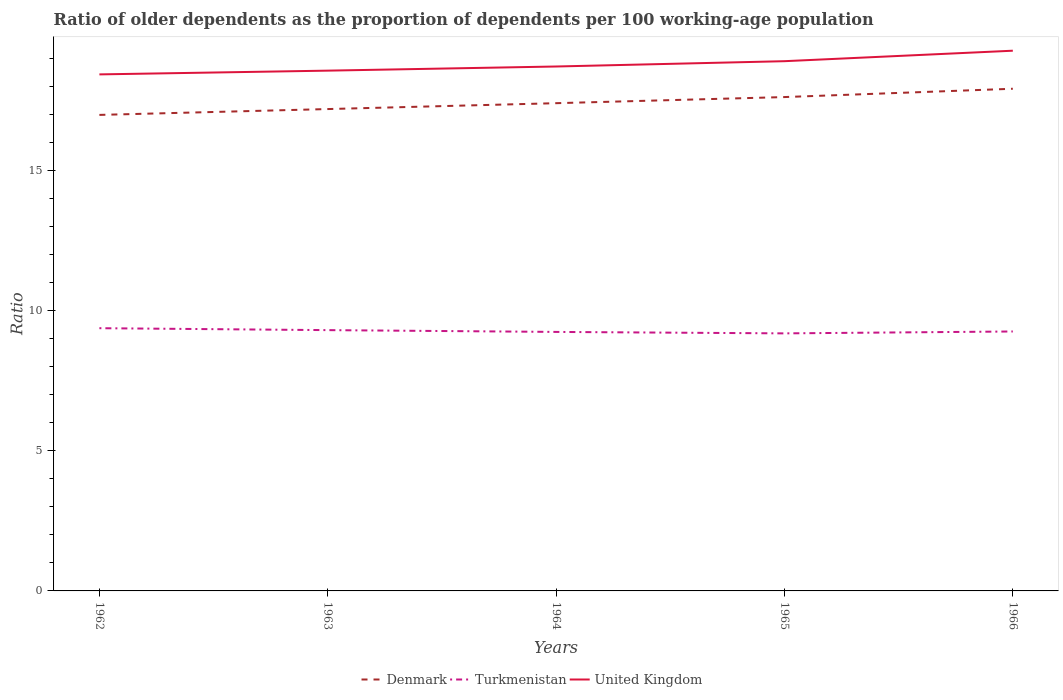How many different coloured lines are there?
Ensure brevity in your answer.  3. Across all years, what is the maximum age dependency ratio(old) in United Kingdom?
Keep it short and to the point. 18.43. In which year was the age dependency ratio(old) in Denmark maximum?
Your answer should be compact. 1962. What is the total age dependency ratio(old) in Denmark in the graph?
Offer a terse response. -0.43. What is the difference between the highest and the second highest age dependency ratio(old) in Denmark?
Make the answer very short. 0.93. How many years are there in the graph?
Provide a succinct answer. 5. Are the values on the major ticks of Y-axis written in scientific E-notation?
Make the answer very short. No. Does the graph contain grids?
Make the answer very short. No. How are the legend labels stacked?
Give a very brief answer. Horizontal. What is the title of the graph?
Give a very brief answer. Ratio of older dependents as the proportion of dependents per 100 working-age population. Does "United Kingdom" appear as one of the legend labels in the graph?
Give a very brief answer. Yes. What is the label or title of the X-axis?
Keep it short and to the point. Years. What is the label or title of the Y-axis?
Your answer should be very brief. Ratio. What is the Ratio in Denmark in 1962?
Provide a succinct answer. 16.98. What is the Ratio of Turkmenistan in 1962?
Your response must be concise. 9.37. What is the Ratio of United Kingdom in 1962?
Your answer should be very brief. 18.43. What is the Ratio in Denmark in 1963?
Provide a succinct answer. 17.19. What is the Ratio in Turkmenistan in 1963?
Ensure brevity in your answer.  9.3. What is the Ratio of United Kingdom in 1963?
Offer a very short reply. 18.56. What is the Ratio of Denmark in 1964?
Give a very brief answer. 17.4. What is the Ratio of Turkmenistan in 1964?
Offer a very short reply. 9.24. What is the Ratio of United Kingdom in 1964?
Your answer should be very brief. 18.71. What is the Ratio of Denmark in 1965?
Offer a very short reply. 17.62. What is the Ratio of Turkmenistan in 1965?
Your response must be concise. 9.19. What is the Ratio of United Kingdom in 1965?
Offer a very short reply. 18.9. What is the Ratio of Denmark in 1966?
Give a very brief answer. 17.91. What is the Ratio in Turkmenistan in 1966?
Offer a very short reply. 9.25. What is the Ratio of United Kingdom in 1966?
Provide a short and direct response. 19.27. Across all years, what is the maximum Ratio in Denmark?
Your response must be concise. 17.91. Across all years, what is the maximum Ratio of Turkmenistan?
Offer a terse response. 9.37. Across all years, what is the maximum Ratio of United Kingdom?
Offer a very short reply. 19.27. Across all years, what is the minimum Ratio of Denmark?
Keep it short and to the point. 16.98. Across all years, what is the minimum Ratio of Turkmenistan?
Your answer should be very brief. 9.19. Across all years, what is the minimum Ratio in United Kingdom?
Ensure brevity in your answer.  18.43. What is the total Ratio of Denmark in the graph?
Provide a succinct answer. 87.1. What is the total Ratio in Turkmenistan in the graph?
Ensure brevity in your answer.  46.36. What is the total Ratio in United Kingdom in the graph?
Offer a terse response. 93.86. What is the difference between the Ratio of Denmark in 1962 and that in 1963?
Make the answer very short. -0.21. What is the difference between the Ratio in Turkmenistan in 1962 and that in 1963?
Ensure brevity in your answer.  0.07. What is the difference between the Ratio in United Kingdom in 1962 and that in 1963?
Keep it short and to the point. -0.13. What is the difference between the Ratio of Denmark in 1962 and that in 1964?
Your answer should be very brief. -0.42. What is the difference between the Ratio in Turkmenistan in 1962 and that in 1964?
Offer a terse response. 0.13. What is the difference between the Ratio in United Kingdom in 1962 and that in 1964?
Ensure brevity in your answer.  -0.28. What is the difference between the Ratio of Denmark in 1962 and that in 1965?
Your answer should be compact. -0.64. What is the difference between the Ratio of Turkmenistan in 1962 and that in 1965?
Ensure brevity in your answer.  0.18. What is the difference between the Ratio of United Kingdom in 1962 and that in 1965?
Offer a very short reply. -0.47. What is the difference between the Ratio of Denmark in 1962 and that in 1966?
Give a very brief answer. -0.93. What is the difference between the Ratio in Turkmenistan in 1962 and that in 1966?
Keep it short and to the point. 0.12. What is the difference between the Ratio in United Kingdom in 1962 and that in 1966?
Your answer should be compact. -0.84. What is the difference between the Ratio in Denmark in 1963 and that in 1964?
Offer a terse response. -0.21. What is the difference between the Ratio in Turkmenistan in 1963 and that in 1964?
Offer a very short reply. 0.06. What is the difference between the Ratio in United Kingdom in 1963 and that in 1964?
Ensure brevity in your answer.  -0.15. What is the difference between the Ratio of Denmark in 1963 and that in 1965?
Your answer should be very brief. -0.43. What is the difference between the Ratio in Turkmenistan in 1963 and that in 1965?
Give a very brief answer. 0.12. What is the difference between the Ratio in United Kingdom in 1963 and that in 1965?
Your answer should be compact. -0.34. What is the difference between the Ratio of Denmark in 1963 and that in 1966?
Your answer should be very brief. -0.72. What is the difference between the Ratio of Turkmenistan in 1963 and that in 1966?
Your answer should be compact. 0.05. What is the difference between the Ratio of United Kingdom in 1963 and that in 1966?
Your answer should be very brief. -0.71. What is the difference between the Ratio of Denmark in 1964 and that in 1965?
Provide a succinct answer. -0.22. What is the difference between the Ratio of Turkmenistan in 1964 and that in 1965?
Provide a succinct answer. 0.05. What is the difference between the Ratio of United Kingdom in 1964 and that in 1965?
Your response must be concise. -0.19. What is the difference between the Ratio of Denmark in 1964 and that in 1966?
Keep it short and to the point. -0.52. What is the difference between the Ratio in Turkmenistan in 1964 and that in 1966?
Make the answer very short. -0.02. What is the difference between the Ratio of United Kingdom in 1964 and that in 1966?
Offer a very short reply. -0.56. What is the difference between the Ratio in Denmark in 1965 and that in 1966?
Your response must be concise. -0.3. What is the difference between the Ratio of Turkmenistan in 1965 and that in 1966?
Offer a very short reply. -0.07. What is the difference between the Ratio in United Kingdom in 1965 and that in 1966?
Your answer should be very brief. -0.37. What is the difference between the Ratio in Denmark in 1962 and the Ratio in Turkmenistan in 1963?
Your answer should be compact. 7.68. What is the difference between the Ratio in Denmark in 1962 and the Ratio in United Kingdom in 1963?
Ensure brevity in your answer.  -1.58. What is the difference between the Ratio of Turkmenistan in 1962 and the Ratio of United Kingdom in 1963?
Make the answer very short. -9.19. What is the difference between the Ratio of Denmark in 1962 and the Ratio of Turkmenistan in 1964?
Make the answer very short. 7.74. What is the difference between the Ratio in Denmark in 1962 and the Ratio in United Kingdom in 1964?
Give a very brief answer. -1.73. What is the difference between the Ratio of Turkmenistan in 1962 and the Ratio of United Kingdom in 1964?
Ensure brevity in your answer.  -9.34. What is the difference between the Ratio in Denmark in 1962 and the Ratio in Turkmenistan in 1965?
Give a very brief answer. 7.79. What is the difference between the Ratio of Denmark in 1962 and the Ratio of United Kingdom in 1965?
Your answer should be very brief. -1.92. What is the difference between the Ratio in Turkmenistan in 1962 and the Ratio in United Kingdom in 1965?
Your response must be concise. -9.52. What is the difference between the Ratio in Denmark in 1962 and the Ratio in Turkmenistan in 1966?
Your answer should be compact. 7.73. What is the difference between the Ratio of Denmark in 1962 and the Ratio of United Kingdom in 1966?
Offer a terse response. -2.29. What is the difference between the Ratio in Turkmenistan in 1962 and the Ratio in United Kingdom in 1966?
Your answer should be compact. -9.9. What is the difference between the Ratio of Denmark in 1963 and the Ratio of Turkmenistan in 1964?
Offer a very short reply. 7.95. What is the difference between the Ratio in Denmark in 1963 and the Ratio in United Kingdom in 1964?
Your response must be concise. -1.52. What is the difference between the Ratio of Turkmenistan in 1963 and the Ratio of United Kingdom in 1964?
Give a very brief answer. -9.4. What is the difference between the Ratio of Denmark in 1963 and the Ratio of Turkmenistan in 1965?
Make the answer very short. 8. What is the difference between the Ratio of Denmark in 1963 and the Ratio of United Kingdom in 1965?
Provide a short and direct response. -1.71. What is the difference between the Ratio of Turkmenistan in 1963 and the Ratio of United Kingdom in 1965?
Your response must be concise. -9.59. What is the difference between the Ratio of Denmark in 1963 and the Ratio of Turkmenistan in 1966?
Your response must be concise. 7.93. What is the difference between the Ratio of Denmark in 1963 and the Ratio of United Kingdom in 1966?
Offer a very short reply. -2.08. What is the difference between the Ratio in Turkmenistan in 1963 and the Ratio in United Kingdom in 1966?
Offer a terse response. -9.97. What is the difference between the Ratio of Denmark in 1964 and the Ratio of Turkmenistan in 1965?
Provide a succinct answer. 8.21. What is the difference between the Ratio in Denmark in 1964 and the Ratio in United Kingdom in 1965?
Give a very brief answer. -1.5. What is the difference between the Ratio in Turkmenistan in 1964 and the Ratio in United Kingdom in 1965?
Make the answer very short. -9.66. What is the difference between the Ratio of Denmark in 1964 and the Ratio of Turkmenistan in 1966?
Provide a short and direct response. 8.14. What is the difference between the Ratio in Denmark in 1964 and the Ratio in United Kingdom in 1966?
Your answer should be very brief. -1.87. What is the difference between the Ratio in Turkmenistan in 1964 and the Ratio in United Kingdom in 1966?
Your answer should be very brief. -10.03. What is the difference between the Ratio of Denmark in 1965 and the Ratio of Turkmenistan in 1966?
Offer a very short reply. 8.36. What is the difference between the Ratio of Denmark in 1965 and the Ratio of United Kingdom in 1966?
Provide a short and direct response. -1.65. What is the difference between the Ratio in Turkmenistan in 1965 and the Ratio in United Kingdom in 1966?
Provide a succinct answer. -10.08. What is the average Ratio in Denmark per year?
Provide a short and direct response. 17.42. What is the average Ratio of Turkmenistan per year?
Make the answer very short. 9.27. What is the average Ratio of United Kingdom per year?
Offer a very short reply. 18.77. In the year 1962, what is the difference between the Ratio of Denmark and Ratio of Turkmenistan?
Make the answer very short. 7.61. In the year 1962, what is the difference between the Ratio of Denmark and Ratio of United Kingdom?
Offer a terse response. -1.45. In the year 1962, what is the difference between the Ratio of Turkmenistan and Ratio of United Kingdom?
Provide a short and direct response. -9.05. In the year 1963, what is the difference between the Ratio in Denmark and Ratio in Turkmenistan?
Provide a succinct answer. 7.89. In the year 1963, what is the difference between the Ratio of Denmark and Ratio of United Kingdom?
Give a very brief answer. -1.37. In the year 1963, what is the difference between the Ratio of Turkmenistan and Ratio of United Kingdom?
Make the answer very short. -9.26. In the year 1964, what is the difference between the Ratio of Denmark and Ratio of Turkmenistan?
Keep it short and to the point. 8.16. In the year 1964, what is the difference between the Ratio of Denmark and Ratio of United Kingdom?
Your response must be concise. -1.31. In the year 1964, what is the difference between the Ratio in Turkmenistan and Ratio in United Kingdom?
Provide a short and direct response. -9.47. In the year 1965, what is the difference between the Ratio in Denmark and Ratio in Turkmenistan?
Offer a terse response. 8.43. In the year 1965, what is the difference between the Ratio of Denmark and Ratio of United Kingdom?
Provide a succinct answer. -1.28. In the year 1965, what is the difference between the Ratio of Turkmenistan and Ratio of United Kingdom?
Your answer should be very brief. -9.71. In the year 1966, what is the difference between the Ratio in Denmark and Ratio in Turkmenistan?
Provide a short and direct response. 8.66. In the year 1966, what is the difference between the Ratio of Denmark and Ratio of United Kingdom?
Provide a short and direct response. -1.36. In the year 1966, what is the difference between the Ratio in Turkmenistan and Ratio in United Kingdom?
Offer a terse response. -10.02. What is the ratio of the Ratio in Denmark in 1962 to that in 1963?
Make the answer very short. 0.99. What is the ratio of the Ratio in Turkmenistan in 1962 to that in 1963?
Provide a short and direct response. 1.01. What is the ratio of the Ratio in United Kingdom in 1962 to that in 1963?
Your answer should be very brief. 0.99. What is the ratio of the Ratio in Turkmenistan in 1962 to that in 1964?
Your answer should be very brief. 1.01. What is the ratio of the Ratio in United Kingdom in 1962 to that in 1964?
Provide a short and direct response. 0.98. What is the ratio of the Ratio of Denmark in 1962 to that in 1965?
Your response must be concise. 0.96. What is the ratio of the Ratio in Turkmenistan in 1962 to that in 1965?
Ensure brevity in your answer.  1.02. What is the ratio of the Ratio of United Kingdom in 1962 to that in 1965?
Give a very brief answer. 0.98. What is the ratio of the Ratio of Denmark in 1962 to that in 1966?
Offer a terse response. 0.95. What is the ratio of the Ratio of Turkmenistan in 1962 to that in 1966?
Your answer should be compact. 1.01. What is the ratio of the Ratio in United Kingdom in 1962 to that in 1966?
Make the answer very short. 0.96. What is the ratio of the Ratio of Denmark in 1963 to that in 1964?
Offer a terse response. 0.99. What is the ratio of the Ratio in United Kingdom in 1963 to that in 1964?
Ensure brevity in your answer.  0.99. What is the ratio of the Ratio in Denmark in 1963 to that in 1965?
Ensure brevity in your answer.  0.98. What is the ratio of the Ratio of Turkmenistan in 1963 to that in 1965?
Offer a terse response. 1.01. What is the ratio of the Ratio of United Kingdom in 1963 to that in 1965?
Ensure brevity in your answer.  0.98. What is the ratio of the Ratio in Denmark in 1963 to that in 1966?
Keep it short and to the point. 0.96. What is the ratio of the Ratio in United Kingdom in 1963 to that in 1966?
Offer a terse response. 0.96. What is the ratio of the Ratio in Denmark in 1964 to that in 1965?
Give a very brief answer. 0.99. What is the ratio of the Ratio of Turkmenistan in 1964 to that in 1965?
Your response must be concise. 1.01. What is the ratio of the Ratio in Denmark in 1964 to that in 1966?
Make the answer very short. 0.97. What is the ratio of the Ratio in Turkmenistan in 1964 to that in 1966?
Your answer should be very brief. 1. What is the ratio of the Ratio in United Kingdom in 1964 to that in 1966?
Ensure brevity in your answer.  0.97. What is the ratio of the Ratio of Denmark in 1965 to that in 1966?
Provide a succinct answer. 0.98. What is the ratio of the Ratio of United Kingdom in 1965 to that in 1966?
Your response must be concise. 0.98. What is the difference between the highest and the second highest Ratio in Denmark?
Your answer should be compact. 0.3. What is the difference between the highest and the second highest Ratio of Turkmenistan?
Provide a short and direct response. 0.07. What is the difference between the highest and the second highest Ratio in United Kingdom?
Offer a terse response. 0.37. What is the difference between the highest and the lowest Ratio in Denmark?
Your answer should be compact. 0.93. What is the difference between the highest and the lowest Ratio of Turkmenistan?
Offer a very short reply. 0.18. What is the difference between the highest and the lowest Ratio of United Kingdom?
Keep it short and to the point. 0.84. 